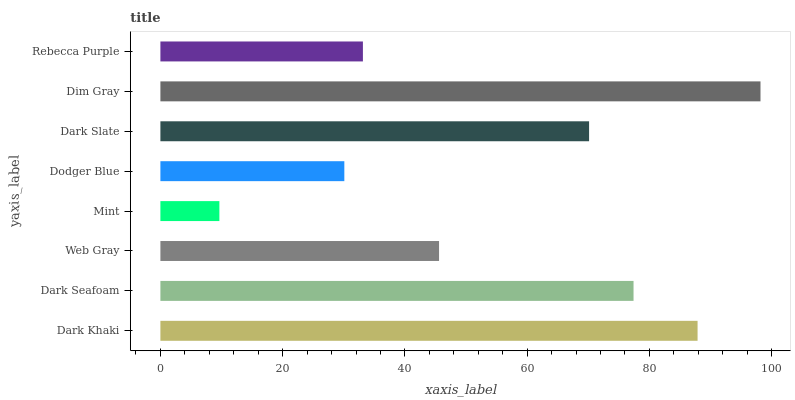Is Mint the minimum?
Answer yes or no. Yes. Is Dim Gray the maximum?
Answer yes or no. Yes. Is Dark Seafoam the minimum?
Answer yes or no. No. Is Dark Seafoam the maximum?
Answer yes or no. No. Is Dark Khaki greater than Dark Seafoam?
Answer yes or no. Yes. Is Dark Seafoam less than Dark Khaki?
Answer yes or no. Yes. Is Dark Seafoam greater than Dark Khaki?
Answer yes or no. No. Is Dark Khaki less than Dark Seafoam?
Answer yes or no. No. Is Dark Slate the high median?
Answer yes or no. Yes. Is Web Gray the low median?
Answer yes or no. Yes. Is Web Gray the high median?
Answer yes or no. No. Is Mint the low median?
Answer yes or no. No. 